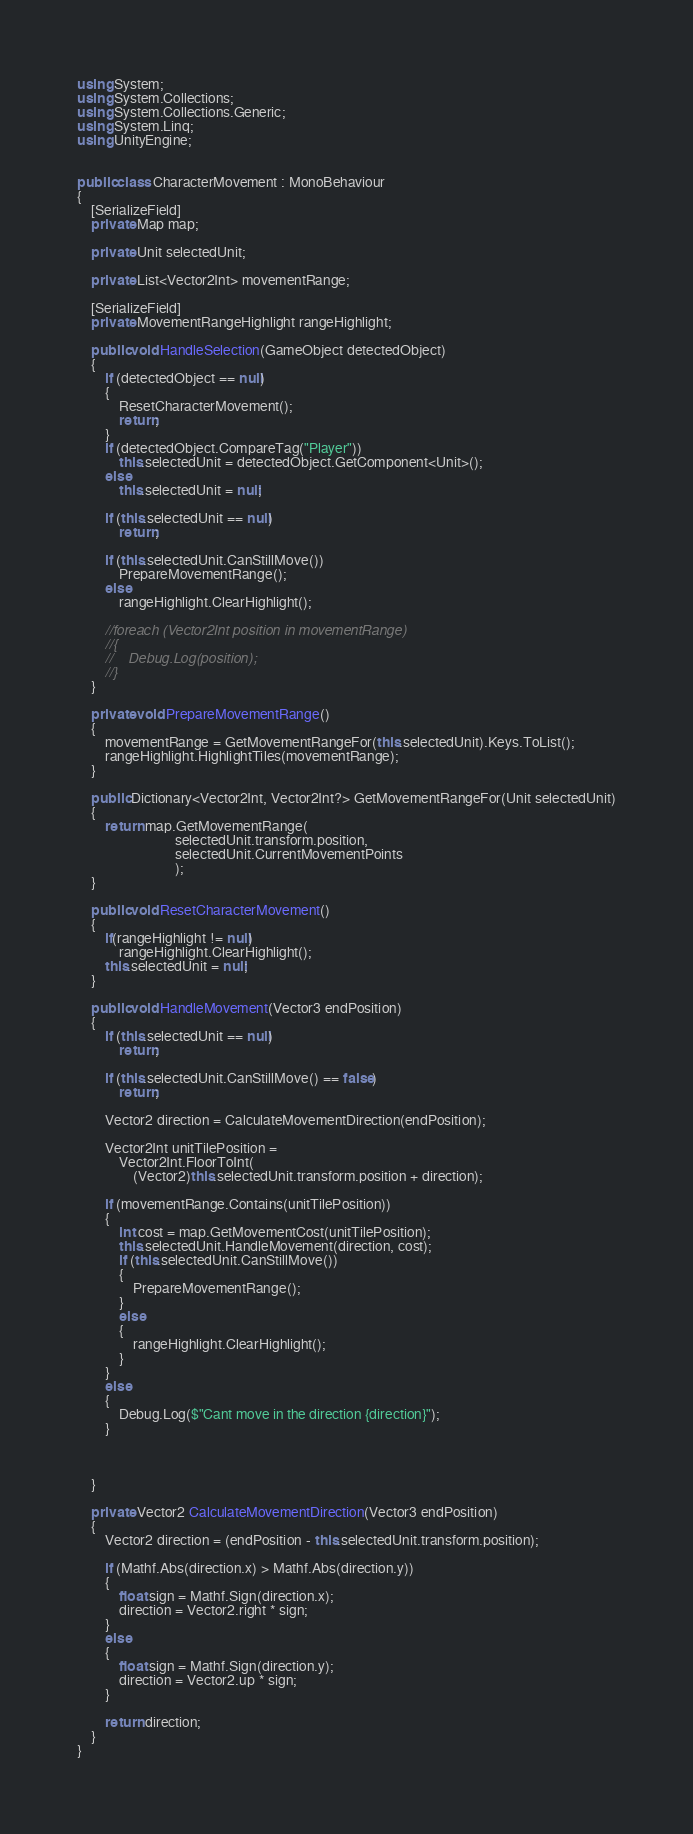Convert code to text. <code><loc_0><loc_0><loc_500><loc_500><_C#_>using System;
using System.Collections;
using System.Collections.Generic;
using System.Linq;
using UnityEngine;


public class CharacterMovement : MonoBehaviour
{
    [SerializeField]
    private Map map;

    private Unit selectedUnit;

    private List<Vector2Int> movementRange;

    [SerializeField]
    private MovementRangeHighlight rangeHighlight;

    public void HandleSelection(GameObject detectedObject)
    {
        if (detectedObject == null)
        {
            ResetCharacterMovement();
            return;
        }
        if (detectedObject.CompareTag("Player"))
            this.selectedUnit = detectedObject.GetComponent<Unit>();
        else
            this.selectedUnit = null;

        if (this.selectedUnit == null)
            return;

        if (this.selectedUnit.CanStillMove())
            PrepareMovementRange();
        else
            rangeHighlight.ClearHighlight();

        //foreach (Vector2Int position in movementRange)
        //{
        //    Debug.Log(position);
        //}
    }

    private void PrepareMovementRange()
    {
        movementRange = GetMovementRangeFor(this.selectedUnit).Keys.ToList();
        rangeHighlight.HighlightTiles(movementRange);
    }

    public Dictionary<Vector2Int, Vector2Int?> GetMovementRangeFor(Unit selectedUnit)
    {
        return map.GetMovementRange(
                            selectedUnit.transform.position,
                            selectedUnit.CurrentMovementPoints
                            );
    }

    public void ResetCharacterMovement()
    {
        if(rangeHighlight != null)
            rangeHighlight.ClearHighlight();
        this.selectedUnit = null;
    }

    public void HandleMovement(Vector3 endPosition)
    {
        if (this.selectedUnit == null)
            return;

        if (this.selectedUnit.CanStillMove() == false)
            return;

        Vector2 direction = CalculateMovementDirection(endPosition);

        Vector2Int unitTilePosition = 
            Vector2Int.FloorToInt(
                (Vector2)this.selectedUnit.transform.position + direction);

        if (movementRange.Contains(unitTilePosition))
        {
            int cost = map.GetMovementCost(unitTilePosition);
            this.selectedUnit.HandleMovement(direction, cost);
            if (this.selectedUnit.CanStillMove())
            {
                PrepareMovementRange();
            }
            else
            {
                rangeHighlight.ClearHighlight();
            }
        }
        else
        {
            Debug.Log($"Cant move in the direction {direction}");
        }

        

    }

    private Vector2 CalculateMovementDirection(Vector3 endPosition)
    {
        Vector2 direction = (endPosition - this.selectedUnit.transform.position);

        if (Mathf.Abs(direction.x) > Mathf.Abs(direction.y))
        {
            float sign = Mathf.Sign(direction.x);
            direction = Vector2.right * sign;
        }
        else
        {
            float sign = Mathf.Sign(direction.y);
            direction = Vector2.up * sign;
        }

        return direction;
    }
}
</code> 